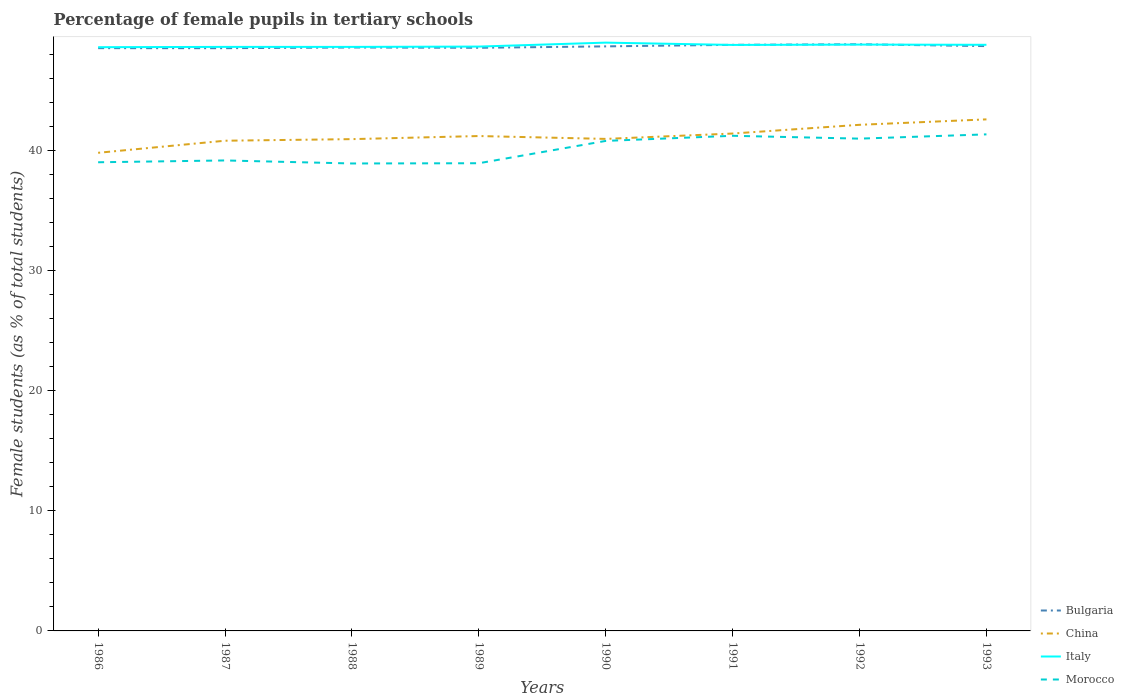How many different coloured lines are there?
Provide a succinct answer. 4. Does the line corresponding to Morocco intersect with the line corresponding to China?
Your response must be concise. No. Is the number of lines equal to the number of legend labels?
Offer a terse response. Yes. Across all years, what is the maximum percentage of female pupils in tertiary schools in Italy?
Offer a very short reply. 48.63. In which year was the percentage of female pupils in tertiary schools in Italy maximum?
Make the answer very short. 1986. What is the total percentage of female pupils in tertiary schools in Bulgaria in the graph?
Offer a terse response. -0.3. What is the difference between the highest and the second highest percentage of female pupils in tertiary schools in Bulgaria?
Your response must be concise. 0.33. What is the difference between the highest and the lowest percentage of female pupils in tertiary schools in Bulgaria?
Give a very brief answer. 4. Is the percentage of female pupils in tertiary schools in China strictly greater than the percentage of female pupils in tertiary schools in Italy over the years?
Your answer should be very brief. Yes. How many lines are there?
Make the answer very short. 4. What is the difference between two consecutive major ticks on the Y-axis?
Your response must be concise. 10. Are the values on the major ticks of Y-axis written in scientific E-notation?
Offer a very short reply. No. Does the graph contain grids?
Your answer should be compact. No. How many legend labels are there?
Your answer should be compact. 4. How are the legend labels stacked?
Your answer should be compact. Vertical. What is the title of the graph?
Make the answer very short. Percentage of female pupils in tertiary schools. Does "Albania" appear as one of the legend labels in the graph?
Offer a terse response. No. What is the label or title of the X-axis?
Your answer should be very brief. Years. What is the label or title of the Y-axis?
Offer a terse response. Female students (as % of total students). What is the Female students (as % of total students) in Bulgaria in 1986?
Ensure brevity in your answer.  48.55. What is the Female students (as % of total students) in China in 1986?
Keep it short and to the point. 39.83. What is the Female students (as % of total students) in Italy in 1986?
Give a very brief answer. 48.63. What is the Female students (as % of total students) in Morocco in 1986?
Offer a terse response. 39.04. What is the Female students (as % of total students) in Bulgaria in 1987?
Your answer should be compact. 48.55. What is the Female students (as % of total students) in China in 1987?
Give a very brief answer. 40.84. What is the Female students (as % of total students) of Italy in 1987?
Your response must be concise. 48.65. What is the Female students (as % of total students) in Morocco in 1987?
Offer a very short reply. 39.19. What is the Female students (as % of total students) of Bulgaria in 1988?
Make the answer very short. 48.6. What is the Female students (as % of total students) in China in 1988?
Provide a short and direct response. 40.97. What is the Female students (as % of total students) of Italy in 1988?
Keep it short and to the point. 48.65. What is the Female students (as % of total students) in Morocco in 1988?
Your answer should be compact. 38.94. What is the Female students (as % of total students) in Bulgaria in 1989?
Make the answer very short. 48.58. What is the Female students (as % of total students) in China in 1989?
Offer a very short reply. 41.23. What is the Female students (as % of total students) of Italy in 1989?
Your response must be concise. 48.68. What is the Female students (as % of total students) of Morocco in 1989?
Offer a very short reply. 38.96. What is the Female students (as % of total students) in Bulgaria in 1990?
Make the answer very short. 48.7. What is the Female students (as % of total students) in China in 1990?
Your answer should be compact. 40.99. What is the Female students (as % of total students) of Italy in 1990?
Make the answer very short. 49.01. What is the Female students (as % of total students) in Morocco in 1990?
Offer a very short reply. 40.82. What is the Female students (as % of total students) of Bulgaria in 1991?
Your answer should be compact. 48.83. What is the Female students (as % of total students) of China in 1991?
Keep it short and to the point. 41.44. What is the Female students (as % of total students) of Italy in 1991?
Give a very brief answer. 48.82. What is the Female students (as % of total students) of Morocco in 1991?
Give a very brief answer. 41.25. What is the Female students (as % of total students) of Bulgaria in 1992?
Your answer should be very brief. 48.87. What is the Female students (as % of total students) of China in 1992?
Give a very brief answer. 42.16. What is the Female students (as % of total students) in Italy in 1992?
Offer a very short reply. 48.85. What is the Female students (as % of total students) of Morocco in 1992?
Your answer should be compact. 41.01. What is the Female students (as % of total students) of Bulgaria in 1993?
Make the answer very short. 48.72. What is the Female students (as % of total students) of China in 1993?
Give a very brief answer. 42.62. What is the Female students (as % of total students) of Italy in 1993?
Your answer should be very brief. 48.83. What is the Female students (as % of total students) in Morocco in 1993?
Your response must be concise. 41.37. Across all years, what is the maximum Female students (as % of total students) in Bulgaria?
Your response must be concise. 48.87. Across all years, what is the maximum Female students (as % of total students) of China?
Your response must be concise. 42.62. Across all years, what is the maximum Female students (as % of total students) in Italy?
Your answer should be compact. 49.01. Across all years, what is the maximum Female students (as % of total students) in Morocco?
Your answer should be compact. 41.37. Across all years, what is the minimum Female students (as % of total students) in Bulgaria?
Make the answer very short. 48.55. Across all years, what is the minimum Female students (as % of total students) of China?
Provide a short and direct response. 39.83. Across all years, what is the minimum Female students (as % of total students) of Italy?
Your response must be concise. 48.63. Across all years, what is the minimum Female students (as % of total students) in Morocco?
Provide a succinct answer. 38.94. What is the total Female students (as % of total students) of Bulgaria in the graph?
Make the answer very short. 389.39. What is the total Female students (as % of total students) in China in the graph?
Your answer should be compact. 330.07. What is the total Female students (as % of total students) in Italy in the graph?
Your answer should be very brief. 390.12. What is the total Female students (as % of total students) in Morocco in the graph?
Ensure brevity in your answer.  320.59. What is the difference between the Female students (as % of total students) of Bulgaria in 1986 and that in 1987?
Ensure brevity in your answer.  0. What is the difference between the Female students (as % of total students) of China in 1986 and that in 1987?
Offer a terse response. -1.01. What is the difference between the Female students (as % of total students) in Italy in 1986 and that in 1987?
Your response must be concise. -0.03. What is the difference between the Female students (as % of total students) in Morocco in 1986 and that in 1987?
Your response must be concise. -0.15. What is the difference between the Female students (as % of total students) of Bulgaria in 1986 and that in 1988?
Give a very brief answer. -0.06. What is the difference between the Female students (as % of total students) of China in 1986 and that in 1988?
Your response must be concise. -1.14. What is the difference between the Female students (as % of total students) in Italy in 1986 and that in 1988?
Offer a very short reply. -0.03. What is the difference between the Female students (as % of total students) in Morocco in 1986 and that in 1988?
Ensure brevity in your answer.  0.1. What is the difference between the Female students (as % of total students) of Bulgaria in 1986 and that in 1989?
Offer a very short reply. -0.03. What is the difference between the Female students (as % of total students) in China in 1986 and that in 1989?
Offer a very short reply. -1.4. What is the difference between the Female students (as % of total students) in Italy in 1986 and that in 1989?
Offer a very short reply. -0.05. What is the difference between the Female students (as % of total students) in Morocco in 1986 and that in 1989?
Make the answer very short. 0.08. What is the difference between the Female students (as % of total students) in Bulgaria in 1986 and that in 1990?
Give a very brief answer. -0.15. What is the difference between the Female students (as % of total students) of China in 1986 and that in 1990?
Your answer should be compact. -1.16. What is the difference between the Female students (as % of total students) in Italy in 1986 and that in 1990?
Provide a short and direct response. -0.38. What is the difference between the Female students (as % of total students) in Morocco in 1986 and that in 1990?
Offer a very short reply. -1.78. What is the difference between the Female students (as % of total students) of Bulgaria in 1986 and that in 1991?
Your answer should be very brief. -0.28. What is the difference between the Female students (as % of total students) of China in 1986 and that in 1991?
Your answer should be compact. -1.61. What is the difference between the Female students (as % of total students) in Italy in 1986 and that in 1991?
Provide a short and direct response. -0.19. What is the difference between the Female students (as % of total students) of Morocco in 1986 and that in 1991?
Offer a terse response. -2.21. What is the difference between the Female students (as % of total students) in Bulgaria in 1986 and that in 1992?
Provide a short and direct response. -0.33. What is the difference between the Female students (as % of total students) in China in 1986 and that in 1992?
Offer a terse response. -2.33. What is the difference between the Female students (as % of total students) of Italy in 1986 and that in 1992?
Ensure brevity in your answer.  -0.22. What is the difference between the Female students (as % of total students) of Morocco in 1986 and that in 1992?
Provide a succinct answer. -1.97. What is the difference between the Female students (as % of total students) in Bulgaria in 1986 and that in 1993?
Your response must be concise. -0.17. What is the difference between the Female students (as % of total students) in China in 1986 and that in 1993?
Make the answer very short. -2.78. What is the difference between the Female students (as % of total students) of Italy in 1986 and that in 1993?
Offer a terse response. -0.2. What is the difference between the Female students (as % of total students) of Morocco in 1986 and that in 1993?
Provide a short and direct response. -2.32. What is the difference between the Female students (as % of total students) of Bulgaria in 1987 and that in 1988?
Ensure brevity in your answer.  -0.06. What is the difference between the Female students (as % of total students) of China in 1987 and that in 1988?
Ensure brevity in your answer.  -0.13. What is the difference between the Female students (as % of total students) of Italy in 1987 and that in 1988?
Offer a terse response. -0. What is the difference between the Female students (as % of total students) of Morocco in 1987 and that in 1988?
Provide a short and direct response. 0.25. What is the difference between the Female students (as % of total students) in Bulgaria in 1987 and that in 1989?
Offer a terse response. -0.03. What is the difference between the Female students (as % of total students) in China in 1987 and that in 1989?
Keep it short and to the point. -0.39. What is the difference between the Female students (as % of total students) of Italy in 1987 and that in 1989?
Offer a terse response. -0.03. What is the difference between the Female students (as % of total students) of Morocco in 1987 and that in 1989?
Offer a very short reply. 0.23. What is the difference between the Female students (as % of total students) of Bulgaria in 1987 and that in 1990?
Your answer should be compact. -0.15. What is the difference between the Female students (as % of total students) of China in 1987 and that in 1990?
Your response must be concise. -0.15. What is the difference between the Female students (as % of total students) in Italy in 1987 and that in 1990?
Provide a short and direct response. -0.36. What is the difference between the Female students (as % of total students) in Morocco in 1987 and that in 1990?
Keep it short and to the point. -1.63. What is the difference between the Female students (as % of total students) of Bulgaria in 1987 and that in 1991?
Keep it short and to the point. -0.28. What is the difference between the Female students (as % of total students) in China in 1987 and that in 1991?
Ensure brevity in your answer.  -0.6. What is the difference between the Female students (as % of total students) in Italy in 1987 and that in 1991?
Make the answer very short. -0.16. What is the difference between the Female students (as % of total students) of Morocco in 1987 and that in 1991?
Provide a succinct answer. -2.05. What is the difference between the Female students (as % of total students) in Bulgaria in 1987 and that in 1992?
Provide a succinct answer. -0.33. What is the difference between the Female students (as % of total students) in China in 1987 and that in 1992?
Keep it short and to the point. -1.33. What is the difference between the Female students (as % of total students) of Italy in 1987 and that in 1992?
Offer a terse response. -0.19. What is the difference between the Female students (as % of total students) of Morocco in 1987 and that in 1992?
Your answer should be compact. -1.82. What is the difference between the Female students (as % of total students) in Bulgaria in 1987 and that in 1993?
Ensure brevity in your answer.  -0.17. What is the difference between the Female students (as % of total students) in China in 1987 and that in 1993?
Offer a very short reply. -1.78. What is the difference between the Female students (as % of total students) of Italy in 1987 and that in 1993?
Your answer should be very brief. -0.18. What is the difference between the Female students (as % of total students) in Morocco in 1987 and that in 1993?
Offer a terse response. -2.17. What is the difference between the Female students (as % of total students) in Bulgaria in 1988 and that in 1989?
Provide a succinct answer. 0.03. What is the difference between the Female students (as % of total students) of China in 1988 and that in 1989?
Your response must be concise. -0.26. What is the difference between the Female students (as % of total students) of Italy in 1988 and that in 1989?
Offer a very short reply. -0.03. What is the difference between the Female students (as % of total students) of Morocco in 1988 and that in 1989?
Keep it short and to the point. -0.02. What is the difference between the Female students (as % of total students) in Bulgaria in 1988 and that in 1990?
Keep it short and to the point. -0.09. What is the difference between the Female students (as % of total students) of China in 1988 and that in 1990?
Give a very brief answer. -0.02. What is the difference between the Female students (as % of total students) of Italy in 1988 and that in 1990?
Ensure brevity in your answer.  -0.36. What is the difference between the Female students (as % of total students) of Morocco in 1988 and that in 1990?
Provide a short and direct response. -1.88. What is the difference between the Female students (as % of total students) of Bulgaria in 1988 and that in 1991?
Your response must be concise. -0.22. What is the difference between the Female students (as % of total students) of China in 1988 and that in 1991?
Give a very brief answer. -0.47. What is the difference between the Female students (as % of total students) in Italy in 1988 and that in 1991?
Your response must be concise. -0.16. What is the difference between the Female students (as % of total students) of Morocco in 1988 and that in 1991?
Ensure brevity in your answer.  -2.31. What is the difference between the Female students (as % of total students) of Bulgaria in 1988 and that in 1992?
Provide a short and direct response. -0.27. What is the difference between the Female students (as % of total students) in China in 1988 and that in 1992?
Make the answer very short. -1.19. What is the difference between the Female students (as % of total students) in Italy in 1988 and that in 1992?
Provide a succinct answer. -0.19. What is the difference between the Female students (as % of total students) of Morocco in 1988 and that in 1992?
Your answer should be very brief. -2.07. What is the difference between the Female students (as % of total students) in Bulgaria in 1988 and that in 1993?
Keep it short and to the point. -0.11. What is the difference between the Female students (as % of total students) of China in 1988 and that in 1993?
Offer a terse response. -1.65. What is the difference between the Female students (as % of total students) of Italy in 1988 and that in 1993?
Ensure brevity in your answer.  -0.17. What is the difference between the Female students (as % of total students) of Morocco in 1988 and that in 1993?
Offer a very short reply. -2.43. What is the difference between the Female students (as % of total students) of Bulgaria in 1989 and that in 1990?
Your answer should be compact. -0.12. What is the difference between the Female students (as % of total students) of China in 1989 and that in 1990?
Your response must be concise. 0.24. What is the difference between the Female students (as % of total students) of Italy in 1989 and that in 1990?
Keep it short and to the point. -0.33. What is the difference between the Female students (as % of total students) of Morocco in 1989 and that in 1990?
Offer a terse response. -1.86. What is the difference between the Female students (as % of total students) in Bulgaria in 1989 and that in 1991?
Offer a very short reply. -0.25. What is the difference between the Female students (as % of total students) of China in 1989 and that in 1991?
Offer a very short reply. -0.21. What is the difference between the Female students (as % of total students) in Italy in 1989 and that in 1991?
Give a very brief answer. -0.14. What is the difference between the Female students (as % of total students) in Morocco in 1989 and that in 1991?
Ensure brevity in your answer.  -2.29. What is the difference between the Female students (as % of total students) of Bulgaria in 1989 and that in 1992?
Offer a terse response. -0.3. What is the difference between the Female students (as % of total students) of China in 1989 and that in 1992?
Offer a very short reply. -0.94. What is the difference between the Female students (as % of total students) of Italy in 1989 and that in 1992?
Provide a succinct answer. -0.17. What is the difference between the Female students (as % of total students) in Morocco in 1989 and that in 1992?
Provide a short and direct response. -2.05. What is the difference between the Female students (as % of total students) in Bulgaria in 1989 and that in 1993?
Your response must be concise. -0.14. What is the difference between the Female students (as % of total students) in China in 1989 and that in 1993?
Provide a short and direct response. -1.39. What is the difference between the Female students (as % of total students) in Italy in 1989 and that in 1993?
Make the answer very short. -0.15. What is the difference between the Female students (as % of total students) of Morocco in 1989 and that in 1993?
Offer a very short reply. -2.4. What is the difference between the Female students (as % of total students) in Bulgaria in 1990 and that in 1991?
Offer a terse response. -0.13. What is the difference between the Female students (as % of total students) of China in 1990 and that in 1991?
Provide a succinct answer. -0.45. What is the difference between the Female students (as % of total students) in Italy in 1990 and that in 1991?
Provide a succinct answer. 0.19. What is the difference between the Female students (as % of total students) of Morocco in 1990 and that in 1991?
Give a very brief answer. -0.43. What is the difference between the Female students (as % of total students) in Bulgaria in 1990 and that in 1992?
Provide a succinct answer. -0.18. What is the difference between the Female students (as % of total students) of China in 1990 and that in 1992?
Your answer should be very brief. -1.17. What is the difference between the Female students (as % of total students) in Italy in 1990 and that in 1992?
Offer a very short reply. 0.16. What is the difference between the Female students (as % of total students) of Morocco in 1990 and that in 1992?
Give a very brief answer. -0.19. What is the difference between the Female students (as % of total students) of Bulgaria in 1990 and that in 1993?
Your answer should be compact. -0.02. What is the difference between the Female students (as % of total students) of China in 1990 and that in 1993?
Your answer should be very brief. -1.63. What is the difference between the Female students (as % of total students) of Italy in 1990 and that in 1993?
Offer a very short reply. 0.18. What is the difference between the Female students (as % of total students) of Morocco in 1990 and that in 1993?
Make the answer very short. -0.54. What is the difference between the Female students (as % of total students) of Bulgaria in 1991 and that in 1992?
Offer a very short reply. -0.05. What is the difference between the Female students (as % of total students) in China in 1991 and that in 1992?
Offer a terse response. -0.73. What is the difference between the Female students (as % of total students) of Italy in 1991 and that in 1992?
Your answer should be compact. -0.03. What is the difference between the Female students (as % of total students) in Morocco in 1991 and that in 1992?
Your response must be concise. 0.24. What is the difference between the Female students (as % of total students) in Bulgaria in 1991 and that in 1993?
Your response must be concise. 0.11. What is the difference between the Female students (as % of total students) in China in 1991 and that in 1993?
Offer a terse response. -1.18. What is the difference between the Female students (as % of total students) of Italy in 1991 and that in 1993?
Your answer should be very brief. -0.01. What is the difference between the Female students (as % of total students) of Morocco in 1991 and that in 1993?
Make the answer very short. -0.12. What is the difference between the Female students (as % of total students) of Bulgaria in 1992 and that in 1993?
Offer a terse response. 0.16. What is the difference between the Female students (as % of total students) in China in 1992 and that in 1993?
Give a very brief answer. -0.45. What is the difference between the Female students (as % of total students) of Italy in 1992 and that in 1993?
Offer a terse response. 0.02. What is the difference between the Female students (as % of total students) of Morocco in 1992 and that in 1993?
Keep it short and to the point. -0.36. What is the difference between the Female students (as % of total students) of Bulgaria in 1986 and the Female students (as % of total students) of China in 1987?
Your answer should be very brief. 7.71. What is the difference between the Female students (as % of total students) in Bulgaria in 1986 and the Female students (as % of total students) in Italy in 1987?
Your response must be concise. -0.11. What is the difference between the Female students (as % of total students) in Bulgaria in 1986 and the Female students (as % of total students) in Morocco in 1987?
Give a very brief answer. 9.35. What is the difference between the Female students (as % of total students) of China in 1986 and the Female students (as % of total students) of Italy in 1987?
Your answer should be very brief. -8.82. What is the difference between the Female students (as % of total students) in China in 1986 and the Female students (as % of total students) in Morocco in 1987?
Make the answer very short. 0.64. What is the difference between the Female students (as % of total students) of Italy in 1986 and the Female students (as % of total students) of Morocco in 1987?
Your answer should be very brief. 9.43. What is the difference between the Female students (as % of total students) in Bulgaria in 1986 and the Female students (as % of total students) in China in 1988?
Make the answer very short. 7.58. What is the difference between the Female students (as % of total students) of Bulgaria in 1986 and the Female students (as % of total students) of Italy in 1988?
Offer a very short reply. -0.11. What is the difference between the Female students (as % of total students) of Bulgaria in 1986 and the Female students (as % of total students) of Morocco in 1988?
Ensure brevity in your answer.  9.61. What is the difference between the Female students (as % of total students) of China in 1986 and the Female students (as % of total students) of Italy in 1988?
Provide a succinct answer. -8.82. What is the difference between the Female students (as % of total students) of China in 1986 and the Female students (as % of total students) of Morocco in 1988?
Keep it short and to the point. 0.89. What is the difference between the Female students (as % of total students) in Italy in 1986 and the Female students (as % of total students) in Morocco in 1988?
Your response must be concise. 9.69. What is the difference between the Female students (as % of total students) in Bulgaria in 1986 and the Female students (as % of total students) in China in 1989?
Give a very brief answer. 7.32. What is the difference between the Female students (as % of total students) in Bulgaria in 1986 and the Female students (as % of total students) in Italy in 1989?
Keep it short and to the point. -0.13. What is the difference between the Female students (as % of total students) of Bulgaria in 1986 and the Female students (as % of total students) of Morocco in 1989?
Ensure brevity in your answer.  9.59. What is the difference between the Female students (as % of total students) in China in 1986 and the Female students (as % of total students) in Italy in 1989?
Provide a succinct answer. -8.85. What is the difference between the Female students (as % of total students) in China in 1986 and the Female students (as % of total students) in Morocco in 1989?
Give a very brief answer. 0.87. What is the difference between the Female students (as % of total students) of Italy in 1986 and the Female students (as % of total students) of Morocco in 1989?
Provide a short and direct response. 9.67. What is the difference between the Female students (as % of total students) of Bulgaria in 1986 and the Female students (as % of total students) of China in 1990?
Give a very brief answer. 7.56. What is the difference between the Female students (as % of total students) of Bulgaria in 1986 and the Female students (as % of total students) of Italy in 1990?
Provide a short and direct response. -0.46. What is the difference between the Female students (as % of total students) of Bulgaria in 1986 and the Female students (as % of total students) of Morocco in 1990?
Ensure brevity in your answer.  7.73. What is the difference between the Female students (as % of total students) of China in 1986 and the Female students (as % of total students) of Italy in 1990?
Your response must be concise. -9.18. What is the difference between the Female students (as % of total students) of China in 1986 and the Female students (as % of total students) of Morocco in 1990?
Make the answer very short. -0.99. What is the difference between the Female students (as % of total students) of Italy in 1986 and the Female students (as % of total students) of Morocco in 1990?
Ensure brevity in your answer.  7.81. What is the difference between the Female students (as % of total students) in Bulgaria in 1986 and the Female students (as % of total students) in China in 1991?
Make the answer very short. 7.11. What is the difference between the Female students (as % of total students) of Bulgaria in 1986 and the Female students (as % of total students) of Italy in 1991?
Make the answer very short. -0.27. What is the difference between the Female students (as % of total students) of Bulgaria in 1986 and the Female students (as % of total students) of Morocco in 1991?
Make the answer very short. 7.3. What is the difference between the Female students (as % of total students) of China in 1986 and the Female students (as % of total students) of Italy in 1991?
Give a very brief answer. -8.99. What is the difference between the Female students (as % of total students) in China in 1986 and the Female students (as % of total students) in Morocco in 1991?
Offer a terse response. -1.42. What is the difference between the Female students (as % of total students) of Italy in 1986 and the Female students (as % of total students) of Morocco in 1991?
Your answer should be very brief. 7.38. What is the difference between the Female students (as % of total students) in Bulgaria in 1986 and the Female students (as % of total students) in China in 1992?
Offer a terse response. 6.39. What is the difference between the Female students (as % of total students) of Bulgaria in 1986 and the Female students (as % of total students) of Italy in 1992?
Keep it short and to the point. -0.3. What is the difference between the Female students (as % of total students) of Bulgaria in 1986 and the Female students (as % of total students) of Morocco in 1992?
Make the answer very short. 7.54. What is the difference between the Female students (as % of total students) in China in 1986 and the Female students (as % of total students) in Italy in 1992?
Ensure brevity in your answer.  -9.02. What is the difference between the Female students (as % of total students) of China in 1986 and the Female students (as % of total students) of Morocco in 1992?
Keep it short and to the point. -1.18. What is the difference between the Female students (as % of total students) of Italy in 1986 and the Female students (as % of total students) of Morocco in 1992?
Provide a succinct answer. 7.62. What is the difference between the Female students (as % of total students) in Bulgaria in 1986 and the Female students (as % of total students) in China in 1993?
Provide a succinct answer. 5.93. What is the difference between the Female students (as % of total students) in Bulgaria in 1986 and the Female students (as % of total students) in Italy in 1993?
Keep it short and to the point. -0.28. What is the difference between the Female students (as % of total students) in Bulgaria in 1986 and the Female students (as % of total students) in Morocco in 1993?
Your response must be concise. 7.18. What is the difference between the Female students (as % of total students) of China in 1986 and the Female students (as % of total students) of Italy in 1993?
Make the answer very short. -9. What is the difference between the Female students (as % of total students) in China in 1986 and the Female students (as % of total students) in Morocco in 1993?
Your response must be concise. -1.54. What is the difference between the Female students (as % of total students) of Italy in 1986 and the Female students (as % of total students) of Morocco in 1993?
Provide a succinct answer. 7.26. What is the difference between the Female students (as % of total students) in Bulgaria in 1987 and the Female students (as % of total students) in China in 1988?
Your response must be concise. 7.58. What is the difference between the Female students (as % of total students) of Bulgaria in 1987 and the Female students (as % of total students) of Italy in 1988?
Keep it short and to the point. -0.11. What is the difference between the Female students (as % of total students) of Bulgaria in 1987 and the Female students (as % of total students) of Morocco in 1988?
Provide a succinct answer. 9.6. What is the difference between the Female students (as % of total students) in China in 1987 and the Female students (as % of total students) in Italy in 1988?
Make the answer very short. -7.82. What is the difference between the Female students (as % of total students) of China in 1987 and the Female students (as % of total students) of Morocco in 1988?
Make the answer very short. 1.9. What is the difference between the Female students (as % of total students) in Italy in 1987 and the Female students (as % of total students) in Morocco in 1988?
Make the answer very short. 9.71. What is the difference between the Female students (as % of total students) of Bulgaria in 1987 and the Female students (as % of total students) of China in 1989?
Your response must be concise. 7.32. What is the difference between the Female students (as % of total students) in Bulgaria in 1987 and the Female students (as % of total students) in Italy in 1989?
Make the answer very short. -0.13. What is the difference between the Female students (as % of total students) in Bulgaria in 1987 and the Female students (as % of total students) in Morocco in 1989?
Offer a terse response. 9.58. What is the difference between the Female students (as % of total students) of China in 1987 and the Female students (as % of total students) of Italy in 1989?
Provide a short and direct response. -7.84. What is the difference between the Female students (as % of total students) in China in 1987 and the Female students (as % of total students) in Morocco in 1989?
Your answer should be compact. 1.88. What is the difference between the Female students (as % of total students) of Italy in 1987 and the Female students (as % of total students) of Morocco in 1989?
Keep it short and to the point. 9.69. What is the difference between the Female students (as % of total students) in Bulgaria in 1987 and the Female students (as % of total students) in China in 1990?
Your response must be concise. 7.56. What is the difference between the Female students (as % of total students) of Bulgaria in 1987 and the Female students (as % of total students) of Italy in 1990?
Make the answer very short. -0.46. What is the difference between the Female students (as % of total students) of Bulgaria in 1987 and the Female students (as % of total students) of Morocco in 1990?
Offer a very short reply. 7.72. What is the difference between the Female students (as % of total students) of China in 1987 and the Female students (as % of total students) of Italy in 1990?
Make the answer very short. -8.17. What is the difference between the Female students (as % of total students) of China in 1987 and the Female students (as % of total students) of Morocco in 1990?
Offer a very short reply. 0.02. What is the difference between the Female students (as % of total students) of Italy in 1987 and the Female students (as % of total students) of Morocco in 1990?
Your answer should be compact. 7.83. What is the difference between the Female students (as % of total students) of Bulgaria in 1987 and the Female students (as % of total students) of China in 1991?
Your answer should be very brief. 7.11. What is the difference between the Female students (as % of total students) in Bulgaria in 1987 and the Female students (as % of total students) in Italy in 1991?
Keep it short and to the point. -0.27. What is the difference between the Female students (as % of total students) in Bulgaria in 1987 and the Female students (as % of total students) in Morocco in 1991?
Your answer should be very brief. 7.3. What is the difference between the Female students (as % of total students) of China in 1987 and the Female students (as % of total students) of Italy in 1991?
Your response must be concise. -7.98. What is the difference between the Female students (as % of total students) in China in 1987 and the Female students (as % of total students) in Morocco in 1991?
Your answer should be compact. -0.41. What is the difference between the Female students (as % of total students) in Italy in 1987 and the Female students (as % of total students) in Morocco in 1991?
Keep it short and to the point. 7.41. What is the difference between the Female students (as % of total students) in Bulgaria in 1987 and the Female students (as % of total students) in China in 1992?
Your response must be concise. 6.38. What is the difference between the Female students (as % of total students) of Bulgaria in 1987 and the Female students (as % of total students) of Italy in 1992?
Provide a short and direct response. -0.3. What is the difference between the Female students (as % of total students) of Bulgaria in 1987 and the Female students (as % of total students) of Morocco in 1992?
Offer a terse response. 7.54. What is the difference between the Female students (as % of total students) in China in 1987 and the Female students (as % of total students) in Italy in 1992?
Offer a terse response. -8.01. What is the difference between the Female students (as % of total students) of China in 1987 and the Female students (as % of total students) of Morocco in 1992?
Provide a short and direct response. -0.17. What is the difference between the Female students (as % of total students) in Italy in 1987 and the Female students (as % of total students) in Morocco in 1992?
Provide a short and direct response. 7.64. What is the difference between the Female students (as % of total students) of Bulgaria in 1987 and the Female students (as % of total students) of China in 1993?
Give a very brief answer. 5.93. What is the difference between the Female students (as % of total students) of Bulgaria in 1987 and the Female students (as % of total students) of Italy in 1993?
Offer a terse response. -0.28. What is the difference between the Female students (as % of total students) of Bulgaria in 1987 and the Female students (as % of total students) of Morocco in 1993?
Provide a succinct answer. 7.18. What is the difference between the Female students (as % of total students) of China in 1987 and the Female students (as % of total students) of Italy in 1993?
Provide a short and direct response. -7.99. What is the difference between the Female students (as % of total students) in China in 1987 and the Female students (as % of total students) in Morocco in 1993?
Your response must be concise. -0.53. What is the difference between the Female students (as % of total students) of Italy in 1987 and the Female students (as % of total students) of Morocco in 1993?
Provide a short and direct response. 7.29. What is the difference between the Female students (as % of total students) of Bulgaria in 1988 and the Female students (as % of total students) of China in 1989?
Make the answer very short. 7.38. What is the difference between the Female students (as % of total students) of Bulgaria in 1988 and the Female students (as % of total students) of Italy in 1989?
Provide a succinct answer. -0.08. What is the difference between the Female students (as % of total students) in Bulgaria in 1988 and the Female students (as % of total students) in Morocco in 1989?
Your answer should be very brief. 9.64. What is the difference between the Female students (as % of total students) of China in 1988 and the Female students (as % of total students) of Italy in 1989?
Your response must be concise. -7.71. What is the difference between the Female students (as % of total students) of China in 1988 and the Female students (as % of total students) of Morocco in 1989?
Ensure brevity in your answer.  2.01. What is the difference between the Female students (as % of total students) in Italy in 1988 and the Female students (as % of total students) in Morocco in 1989?
Provide a succinct answer. 9.69. What is the difference between the Female students (as % of total students) of Bulgaria in 1988 and the Female students (as % of total students) of China in 1990?
Offer a very short reply. 7.62. What is the difference between the Female students (as % of total students) in Bulgaria in 1988 and the Female students (as % of total students) in Italy in 1990?
Ensure brevity in your answer.  -0.41. What is the difference between the Female students (as % of total students) in Bulgaria in 1988 and the Female students (as % of total students) in Morocco in 1990?
Your answer should be very brief. 7.78. What is the difference between the Female students (as % of total students) of China in 1988 and the Female students (as % of total students) of Italy in 1990?
Provide a short and direct response. -8.04. What is the difference between the Female students (as % of total students) of China in 1988 and the Female students (as % of total students) of Morocco in 1990?
Make the answer very short. 0.15. What is the difference between the Female students (as % of total students) of Italy in 1988 and the Female students (as % of total students) of Morocco in 1990?
Make the answer very short. 7.83. What is the difference between the Female students (as % of total students) of Bulgaria in 1988 and the Female students (as % of total students) of China in 1991?
Provide a short and direct response. 7.17. What is the difference between the Female students (as % of total students) in Bulgaria in 1988 and the Female students (as % of total students) in Italy in 1991?
Provide a succinct answer. -0.21. What is the difference between the Female students (as % of total students) in Bulgaria in 1988 and the Female students (as % of total students) in Morocco in 1991?
Ensure brevity in your answer.  7.36. What is the difference between the Female students (as % of total students) in China in 1988 and the Female students (as % of total students) in Italy in 1991?
Make the answer very short. -7.85. What is the difference between the Female students (as % of total students) in China in 1988 and the Female students (as % of total students) in Morocco in 1991?
Offer a terse response. -0.28. What is the difference between the Female students (as % of total students) in Italy in 1988 and the Female students (as % of total students) in Morocco in 1991?
Make the answer very short. 7.41. What is the difference between the Female students (as % of total students) of Bulgaria in 1988 and the Female students (as % of total students) of China in 1992?
Your response must be concise. 6.44. What is the difference between the Female students (as % of total students) in Bulgaria in 1988 and the Female students (as % of total students) in Italy in 1992?
Offer a very short reply. -0.24. What is the difference between the Female students (as % of total students) in Bulgaria in 1988 and the Female students (as % of total students) in Morocco in 1992?
Make the answer very short. 7.59. What is the difference between the Female students (as % of total students) of China in 1988 and the Female students (as % of total students) of Italy in 1992?
Offer a very short reply. -7.88. What is the difference between the Female students (as % of total students) of China in 1988 and the Female students (as % of total students) of Morocco in 1992?
Make the answer very short. -0.04. What is the difference between the Female students (as % of total students) of Italy in 1988 and the Female students (as % of total students) of Morocco in 1992?
Provide a succinct answer. 7.64. What is the difference between the Female students (as % of total students) in Bulgaria in 1988 and the Female students (as % of total students) in China in 1993?
Offer a terse response. 5.99. What is the difference between the Female students (as % of total students) in Bulgaria in 1988 and the Female students (as % of total students) in Italy in 1993?
Your response must be concise. -0.22. What is the difference between the Female students (as % of total students) of Bulgaria in 1988 and the Female students (as % of total students) of Morocco in 1993?
Make the answer very short. 7.24. What is the difference between the Female students (as % of total students) in China in 1988 and the Female students (as % of total students) in Italy in 1993?
Your answer should be very brief. -7.86. What is the difference between the Female students (as % of total students) in China in 1988 and the Female students (as % of total students) in Morocco in 1993?
Your answer should be very brief. -0.4. What is the difference between the Female students (as % of total students) in Italy in 1988 and the Female students (as % of total students) in Morocco in 1993?
Your answer should be very brief. 7.29. What is the difference between the Female students (as % of total students) of Bulgaria in 1989 and the Female students (as % of total students) of China in 1990?
Your answer should be very brief. 7.59. What is the difference between the Female students (as % of total students) in Bulgaria in 1989 and the Female students (as % of total students) in Italy in 1990?
Give a very brief answer. -0.43. What is the difference between the Female students (as % of total students) of Bulgaria in 1989 and the Female students (as % of total students) of Morocco in 1990?
Keep it short and to the point. 7.76. What is the difference between the Female students (as % of total students) in China in 1989 and the Female students (as % of total students) in Italy in 1990?
Your response must be concise. -7.78. What is the difference between the Female students (as % of total students) in China in 1989 and the Female students (as % of total students) in Morocco in 1990?
Your response must be concise. 0.41. What is the difference between the Female students (as % of total students) of Italy in 1989 and the Female students (as % of total students) of Morocco in 1990?
Offer a terse response. 7.86. What is the difference between the Female students (as % of total students) in Bulgaria in 1989 and the Female students (as % of total students) in China in 1991?
Your answer should be very brief. 7.14. What is the difference between the Female students (as % of total students) in Bulgaria in 1989 and the Female students (as % of total students) in Italy in 1991?
Offer a terse response. -0.24. What is the difference between the Female students (as % of total students) in Bulgaria in 1989 and the Female students (as % of total students) in Morocco in 1991?
Offer a very short reply. 7.33. What is the difference between the Female students (as % of total students) in China in 1989 and the Female students (as % of total students) in Italy in 1991?
Your answer should be very brief. -7.59. What is the difference between the Female students (as % of total students) of China in 1989 and the Female students (as % of total students) of Morocco in 1991?
Make the answer very short. -0.02. What is the difference between the Female students (as % of total students) in Italy in 1989 and the Female students (as % of total students) in Morocco in 1991?
Make the answer very short. 7.43. What is the difference between the Female students (as % of total students) of Bulgaria in 1989 and the Female students (as % of total students) of China in 1992?
Ensure brevity in your answer.  6.42. What is the difference between the Female students (as % of total students) of Bulgaria in 1989 and the Female students (as % of total students) of Italy in 1992?
Offer a very short reply. -0.27. What is the difference between the Female students (as % of total students) in Bulgaria in 1989 and the Female students (as % of total students) in Morocco in 1992?
Provide a succinct answer. 7.57. What is the difference between the Female students (as % of total students) in China in 1989 and the Female students (as % of total students) in Italy in 1992?
Provide a short and direct response. -7.62. What is the difference between the Female students (as % of total students) of China in 1989 and the Female students (as % of total students) of Morocco in 1992?
Provide a short and direct response. 0.22. What is the difference between the Female students (as % of total students) in Italy in 1989 and the Female students (as % of total students) in Morocco in 1992?
Offer a very short reply. 7.67. What is the difference between the Female students (as % of total students) in Bulgaria in 1989 and the Female students (as % of total students) in China in 1993?
Provide a succinct answer. 5.96. What is the difference between the Female students (as % of total students) in Bulgaria in 1989 and the Female students (as % of total students) in Italy in 1993?
Offer a terse response. -0.25. What is the difference between the Female students (as % of total students) of Bulgaria in 1989 and the Female students (as % of total students) of Morocco in 1993?
Provide a short and direct response. 7.21. What is the difference between the Female students (as % of total students) of China in 1989 and the Female students (as % of total students) of Italy in 1993?
Make the answer very short. -7.6. What is the difference between the Female students (as % of total students) in China in 1989 and the Female students (as % of total students) in Morocco in 1993?
Your answer should be very brief. -0.14. What is the difference between the Female students (as % of total students) in Italy in 1989 and the Female students (as % of total students) in Morocco in 1993?
Ensure brevity in your answer.  7.31. What is the difference between the Female students (as % of total students) in Bulgaria in 1990 and the Female students (as % of total students) in China in 1991?
Your answer should be very brief. 7.26. What is the difference between the Female students (as % of total students) of Bulgaria in 1990 and the Female students (as % of total students) of Italy in 1991?
Provide a succinct answer. -0.12. What is the difference between the Female students (as % of total students) of Bulgaria in 1990 and the Female students (as % of total students) of Morocco in 1991?
Make the answer very short. 7.45. What is the difference between the Female students (as % of total students) of China in 1990 and the Female students (as % of total students) of Italy in 1991?
Your answer should be compact. -7.83. What is the difference between the Female students (as % of total students) in China in 1990 and the Female students (as % of total students) in Morocco in 1991?
Your response must be concise. -0.26. What is the difference between the Female students (as % of total students) of Italy in 1990 and the Female students (as % of total students) of Morocco in 1991?
Offer a terse response. 7.76. What is the difference between the Female students (as % of total students) in Bulgaria in 1990 and the Female students (as % of total students) in China in 1992?
Provide a succinct answer. 6.53. What is the difference between the Female students (as % of total students) in Bulgaria in 1990 and the Female students (as % of total students) in Italy in 1992?
Provide a short and direct response. -0.15. What is the difference between the Female students (as % of total students) in Bulgaria in 1990 and the Female students (as % of total students) in Morocco in 1992?
Make the answer very short. 7.69. What is the difference between the Female students (as % of total students) of China in 1990 and the Female students (as % of total students) of Italy in 1992?
Provide a short and direct response. -7.86. What is the difference between the Female students (as % of total students) in China in 1990 and the Female students (as % of total students) in Morocco in 1992?
Provide a succinct answer. -0.02. What is the difference between the Female students (as % of total students) of Italy in 1990 and the Female students (as % of total students) of Morocco in 1992?
Your answer should be compact. 8. What is the difference between the Female students (as % of total students) in Bulgaria in 1990 and the Female students (as % of total students) in China in 1993?
Offer a terse response. 6.08. What is the difference between the Female students (as % of total students) in Bulgaria in 1990 and the Female students (as % of total students) in Italy in 1993?
Your answer should be very brief. -0.13. What is the difference between the Female students (as % of total students) of Bulgaria in 1990 and the Female students (as % of total students) of Morocco in 1993?
Offer a terse response. 7.33. What is the difference between the Female students (as % of total students) of China in 1990 and the Female students (as % of total students) of Italy in 1993?
Give a very brief answer. -7.84. What is the difference between the Female students (as % of total students) of China in 1990 and the Female students (as % of total students) of Morocco in 1993?
Keep it short and to the point. -0.38. What is the difference between the Female students (as % of total students) of Italy in 1990 and the Female students (as % of total students) of Morocco in 1993?
Keep it short and to the point. 7.64. What is the difference between the Female students (as % of total students) of Bulgaria in 1991 and the Female students (as % of total students) of China in 1992?
Make the answer very short. 6.66. What is the difference between the Female students (as % of total students) in Bulgaria in 1991 and the Female students (as % of total students) in Italy in 1992?
Your answer should be very brief. -0.02. What is the difference between the Female students (as % of total students) of Bulgaria in 1991 and the Female students (as % of total students) of Morocco in 1992?
Your answer should be compact. 7.82. What is the difference between the Female students (as % of total students) of China in 1991 and the Female students (as % of total students) of Italy in 1992?
Your answer should be very brief. -7.41. What is the difference between the Female students (as % of total students) of China in 1991 and the Female students (as % of total students) of Morocco in 1992?
Offer a very short reply. 0.43. What is the difference between the Female students (as % of total students) in Italy in 1991 and the Female students (as % of total students) in Morocco in 1992?
Give a very brief answer. 7.81. What is the difference between the Female students (as % of total students) in Bulgaria in 1991 and the Female students (as % of total students) in China in 1993?
Make the answer very short. 6.21. What is the difference between the Female students (as % of total students) in Bulgaria in 1991 and the Female students (as % of total students) in Italy in 1993?
Offer a very short reply. -0. What is the difference between the Female students (as % of total students) of Bulgaria in 1991 and the Female students (as % of total students) of Morocco in 1993?
Ensure brevity in your answer.  7.46. What is the difference between the Female students (as % of total students) in China in 1991 and the Female students (as % of total students) in Italy in 1993?
Your answer should be very brief. -7.39. What is the difference between the Female students (as % of total students) of China in 1991 and the Female students (as % of total students) of Morocco in 1993?
Provide a short and direct response. 0.07. What is the difference between the Female students (as % of total students) in Italy in 1991 and the Female students (as % of total students) in Morocco in 1993?
Ensure brevity in your answer.  7.45. What is the difference between the Female students (as % of total students) of Bulgaria in 1992 and the Female students (as % of total students) of China in 1993?
Your response must be concise. 6.26. What is the difference between the Female students (as % of total students) in Bulgaria in 1992 and the Female students (as % of total students) in Italy in 1993?
Give a very brief answer. 0.04. What is the difference between the Female students (as % of total students) of Bulgaria in 1992 and the Female students (as % of total students) of Morocco in 1993?
Provide a succinct answer. 7.51. What is the difference between the Female students (as % of total students) of China in 1992 and the Female students (as % of total students) of Italy in 1993?
Provide a short and direct response. -6.67. What is the difference between the Female students (as % of total students) of China in 1992 and the Female students (as % of total students) of Morocco in 1993?
Your answer should be compact. 0.8. What is the difference between the Female students (as % of total students) in Italy in 1992 and the Female students (as % of total students) in Morocco in 1993?
Make the answer very short. 7.48. What is the average Female students (as % of total students) of Bulgaria per year?
Your answer should be very brief. 48.67. What is the average Female students (as % of total students) of China per year?
Provide a succinct answer. 41.26. What is the average Female students (as % of total students) of Italy per year?
Offer a terse response. 48.76. What is the average Female students (as % of total students) in Morocco per year?
Provide a short and direct response. 40.07. In the year 1986, what is the difference between the Female students (as % of total students) of Bulgaria and Female students (as % of total students) of China?
Offer a very short reply. 8.72. In the year 1986, what is the difference between the Female students (as % of total students) in Bulgaria and Female students (as % of total students) in Italy?
Offer a very short reply. -0.08. In the year 1986, what is the difference between the Female students (as % of total students) of Bulgaria and Female students (as % of total students) of Morocco?
Your answer should be very brief. 9.51. In the year 1986, what is the difference between the Female students (as % of total students) of China and Female students (as % of total students) of Italy?
Your answer should be compact. -8.8. In the year 1986, what is the difference between the Female students (as % of total students) in China and Female students (as % of total students) in Morocco?
Give a very brief answer. 0.79. In the year 1986, what is the difference between the Female students (as % of total students) in Italy and Female students (as % of total students) in Morocco?
Your answer should be compact. 9.59. In the year 1987, what is the difference between the Female students (as % of total students) of Bulgaria and Female students (as % of total students) of China?
Provide a succinct answer. 7.71. In the year 1987, what is the difference between the Female students (as % of total students) in Bulgaria and Female students (as % of total students) in Italy?
Provide a succinct answer. -0.11. In the year 1987, what is the difference between the Female students (as % of total students) of Bulgaria and Female students (as % of total students) of Morocco?
Your answer should be compact. 9.35. In the year 1987, what is the difference between the Female students (as % of total students) in China and Female students (as % of total students) in Italy?
Provide a succinct answer. -7.82. In the year 1987, what is the difference between the Female students (as % of total students) in China and Female students (as % of total students) in Morocco?
Your response must be concise. 1.64. In the year 1987, what is the difference between the Female students (as % of total students) of Italy and Female students (as % of total students) of Morocco?
Offer a terse response. 9.46. In the year 1988, what is the difference between the Female students (as % of total students) of Bulgaria and Female students (as % of total students) of China?
Offer a terse response. 7.63. In the year 1988, what is the difference between the Female students (as % of total students) in Bulgaria and Female students (as % of total students) in Italy?
Your answer should be compact. -0.05. In the year 1988, what is the difference between the Female students (as % of total students) of Bulgaria and Female students (as % of total students) of Morocco?
Provide a succinct answer. 9.66. In the year 1988, what is the difference between the Female students (as % of total students) of China and Female students (as % of total students) of Italy?
Provide a succinct answer. -7.68. In the year 1988, what is the difference between the Female students (as % of total students) of China and Female students (as % of total students) of Morocco?
Give a very brief answer. 2.03. In the year 1988, what is the difference between the Female students (as % of total students) of Italy and Female students (as % of total students) of Morocco?
Your answer should be very brief. 9.71. In the year 1989, what is the difference between the Female students (as % of total students) in Bulgaria and Female students (as % of total students) in China?
Your answer should be compact. 7.35. In the year 1989, what is the difference between the Female students (as % of total students) of Bulgaria and Female students (as % of total students) of Italy?
Offer a very short reply. -0.1. In the year 1989, what is the difference between the Female students (as % of total students) in Bulgaria and Female students (as % of total students) in Morocco?
Your answer should be compact. 9.62. In the year 1989, what is the difference between the Female students (as % of total students) of China and Female students (as % of total students) of Italy?
Provide a short and direct response. -7.45. In the year 1989, what is the difference between the Female students (as % of total students) in China and Female students (as % of total students) in Morocco?
Provide a short and direct response. 2.27. In the year 1989, what is the difference between the Female students (as % of total students) in Italy and Female students (as % of total students) in Morocco?
Provide a short and direct response. 9.72. In the year 1990, what is the difference between the Female students (as % of total students) of Bulgaria and Female students (as % of total students) of China?
Make the answer very short. 7.71. In the year 1990, what is the difference between the Female students (as % of total students) of Bulgaria and Female students (as % of total students) of Italy?
Provide a short and direct response. -0.31. In the year 1990, what is the difference between the Female students (as % of total students) of Bulgaria and Female students (as % of total students) of Morocco?
Ensure brevity in your answer.  7.88. In the year 1990, what is the difference between the Female students (as % of total students) in China and Female students (as % of total students) in Italy?
Provide a short and direct response. -8.02. In the year 1990, what is the difference between the Female students (as % of total students) of China and Female students (as % of total students) of Morocco?
Ensure brevity in your answer.  0.17. In the year 1990, what is the difference between the Female students (as % of total students) in Italy and Female students (as % of total students) in Morocco?
Keep it short and to the point. 8.19. In the year 1991, what is the difference between the Female students (as % of total students) in Bulgaria and Female students (as % of total students) in China?
Provide a succinct answer. 7.39. In the year 1991, what is the difference between the Female students (as % of total students) of Bulgaria and Female students (as % of total students) of Italy?
Your answer should be very brief. 0.01. In the year 1991, what is the difference between the Female students (as % of total students) in Bulgaria and Female students (as % of total students) in Morocco?
Provide a short and direct response. 7.58. In the year 1991, what is the difference between the Female students (as % of total students) of China and Female students (as % of total students) of Italy?
Your answer should be compact. -7.38. In the year 1991, what is the difference between the Female students (as % of total students) of China and Female students (as % of total students) of Morocco?
Offer a very short reply. 0.19. In the year 1991, what is the difference between the Female students (as % of total students) in Italy and Female students (as % of total students) in Morocco?
Provide a short and direct response. 7.57. In the year 1992, what is the difference between the Female students (as % of total students) of Bulgaria and Female students (as % of total students) of China?
Keep it short and to the point. 6.71. In the year 1992, what is the difference between the Female students (as % of total students) in Bulgaria and Female students (as % of total students) in Italy?
Provide a succinct answer. 0.03. In the year 1992, what is the difference between the Female students (as % of total students) in Bulgaria and Female students (as % of total students) in Morocco?
Offer a terse response. 7.86. In the year 1992, what is the difference between the Female students (as % of total students) of China and Female students (as % of total students) of Italy?
Your answer should be compact. -6.68. In the year 1992, what is the difference between the Female students (as % of total students) of China and Female students (as % of total students) of Morocco?
Give a very brief answer. 1.15. In the year 1992, what is the difference between the Female students (as % of total students) in Italy and Female students (as % of total students) in Morocco?
Your answer should be very brief. 7.84. In the year 1993, what is the difference between the Female students (as % of total students) in Bulgaria and Female students (as % of total students) in China?
Provide a succinct answer. 6.1. In the year 1993, what is the difference between the Female students (as % of total students) in Bulgaria and Female students (as % of total students) in Italy?
Keep it short and to the point. -0.11. In the year 1993, what is the difference between the Female students (as % of total students) in Bulgaria and Female students (as % of total students) in Morocco?
Offer a terse response. 7.35. In the year 1993, what is the difference between the Female students (as % of total students) in China and Female students (as % of total students) in Italy?
Your response must be concise. -6.21. In the year 1993, what is the difference between the Female students (as % of total students) of China and Female students (as % of total students) of Morocco?
Ensure brevity in your answer.  1.25. In the year 1993, what is the difference between the Female students (as % of total students) of Italy and Female students (as % of total students) of Morocco?
Your answer should be compact. 7.46. What is the ratio of the Female students (as % of total students) of Bulgaria in 1986 to that in 1987?
Offer a terse response. 1. What is the ratio of the Female students (as % of total students) of China in 1986 to that in 1987?
Keep it short and to the point. 0.98. What is the ratio of the Female students (as % of total students) of Morocco in 1986 to that in 1987?
Ensure brevity in your answer.  1. What is the ratio of the Female students (as % of total students) of Bulgaria in 1986 to that in 1988?
Your answer should be compact. 1. What is the ratio of the Female students (as % of total students) in China in 1986 to that in 1988?
Provide a succinct answer. 0.97. What is the ratio of the Female students (as % of total students) in Italy in 1986 to that in 1988?
Ensure brevity in your answer.  1. What is the ratio of the Female students (as % of total students) in Morocco in 1986 to that in 1988?
Ensure brevity in your answer.  1. What is the ratio of the Female students (as % of total students) in China in 1986 to that in 1989?
Keep it short and to the point. 0.97. What is the ratio of the Female students (as % of total students) in Morocco in 1986 to that in 1989?
Offer a terse response. 1. What is the ratio of the Female students (as % of total students) in China in 1986 to that in 1990?
Provide a succinct answer. 0.97. What is the ratio of the Female students (as % of total students) in Morocco in 1986 to that in 1990?
Provide a succinct answer. 0.96. What is the ratio of the Female students (as % of total students) of Bulgaria in 1986 to that in 1991?
Provide a succinct answer. 0.99. What is the ratio of the Female students (as % of total students) in China in 1986 to that in 1991?
Offer a very short reply. 0.96. What is the ratio of the Female students (as % of total students) in Morocco in 1986 to that in 1991?
Your answer should be very brief. 0.95. What is the ratio of the Female students (as % of total students) in Bulgaria in 1986 to that in 1992?
Provide a succinct answer. 0.99. What is the ratio of the Female students (as % of total students) in China in 1986 to that in 1992?
Keep it short and to the point. 0.94. What is the ratio of the Female students (as % of total students) in Morocco in 1986 to that in 1992?
Make the answer very short. 0.95. What is the ratio of the Female students (as % of total students) of Bulgaria in 1986 to that in 1993?
Provide a succinct answer. 1. What is the ratio of the Female students (as % of total students) of China in 1986 to that in 1993?
Your response must be concise. 0.93. What is the ratio of the Female students (as % of total students) in Morocco in 1986 to that in 1993?
Make the answer very short. 0.94. What is the ratio of the Female students (as % of total students) of China in 1987 to that in 1988?
Provide a short and direct response. 1. What is the ratio of the Female students (as % of total students) of Morocco in 1987 to that in 1988?
Offer a very short reply. 1.01. What is the ratio of the Female students (as % of total students) of Morocco in 1987 to that in 1989?
Ensure brevity in your answer.  1.01. What is the ratio of the Female students (as % of total students) in Italy in 1987 to that in 1990?
Your answer should be very brief. 0.99. What is the ratio of the Female students (as % of total students) in Morocco in 1987 to that in 1990?
Make the answer very short. 0.96. What is the ratio of the Female students (as % of total students) in China in 1987 to that in 1991?
Your answer should be very brief. 0.99. What is the ratio of the Female students (as % of total students) in Italy in 1987 to that in 1991?
Your answer should be compact. 1. What is the ratio of the Female students (as % of total students) of Morocco in 1987 to that in 1991?
Give a very brief answer. 0.95. What is the ratio of the Female students (as % of total students) of Bulgaria in 1987 to that in 1992?
Provide a short and direct response. 0.99. What is the ratio of the Female students (as % of total students) in China in 1987 to that in 1992?
Make the answer very short. 0.97. What is the ratio of the Female students (as % of total students) of Italy in 1987 to that in 1992?
Offer a terse response. 1. What is the ratio of the Female students (as % of total students) in Morocco in 1987 to that in 1992?
Offer a terse response. 0.96. What is the ratio of the Female students (as % of total students) in China in 1987 to that in 1993?
Ensure brevity in your answer.  0.96. What is the ratio of the Female students (as % of total students) in Morocco in 1987 to that in 1993?
Give a very brief answer. 0.95. What is the ratio of the Female students (as % of total students) of China in 1988 to that in 1989?
Give a very brief answer. 0.99. What is the ratio of the Female students (as % of total students) in Italy in 1988 to that in 1989?
Your answer should be very brief. 1. What is the ratio of the Female students (as % of total students) in Morocco in 1988 to that in 1989?
Your answer should be compact. 1. What is the ratio of the Female students (as % of total students) of Morocco in 1988 to that in 1990?
Offer a very short reply. 0.95. What is the ratio of the Female students (as % of total students) of China in 1988 to that in 1991?
Offer a very short reply. 0.99. What is the ratio of the Female students (as % of total students) in Morocco in 1988 to that in 1991?
Make the answer very short. 0.94. What is the ratio of the Female students (as % of total students) in China in 1988 to that in 1992?
Provide a succinct answer. 0.97. What is the ratio of the Female students (as % of total students) of Morocco in 1988 to that in 1992?
Provide a succinct answer. 0.95. What is the ratio of the Female students (as % of total students) of Bulgaria in 1988 to that in 1993?
Ensure brevity in your answer.  1. What is the ratio of the Female students (as % of total students) of China in 1988 to that in 1993?
Provide a short and direct response. 0.96. What is the ratio of the Female students (as % of total students) in Morocco in 1988 to that in 1993?
Keep it short and to the point. 0.94. What is the ratio of the Female students (as % of total students) in China in 1989 to that in 1990?
Make the answer very short. 1.01. What is the ratio of the Female students (as % of total students) of Italy in 1989 to that in 1990?
Offer a very short reply. 0.99. What is the ratio of the Female students (as % of total students) of Morocco in 1989 to that in 1990?
Offer a terse response. 0.95. What is the ratio of the Female students (as % of total students) of Bulgaria in 1989 to that in 1991?
Make the answer very short. 0.99. What is the ratio of the Female students (as % of total students) in Morocco in 1989 to that in 1991?
Your answer should be compact. 0.94. What is the ratio of the Female students (as % of total students) of China in 1989 to that in 1992?
Offer a very short reply. 0.98. What is the ratio of the Female students (as % of total students) of Bulgaria in 1989 to that in 1993?
Keep it short and to the point. 1. What is the ratio of the Female students (as % of total students) in China in 1989 to that in 1993?
Ensure brevity in your answer.  0.97. What is the ratio of the Female students (as % of total students) in Italy in 1989 to that in 1993?
Give a very brief answer. 1. What is the ratio of the Female students (as % of total students) of Morocco in 1989 to that in 1993?
Ensure brevity in your answer.  0.94. What is the ratio of the Female students (as % of total students) of China in 1990 to that in 1991?
Provide a short and direct response. 0.99. What is the ratio of the Female students (as % of total students) of Italy in 1990 to that in 1991?
Offer a very short reply. 1. What is the ratio of the Female students (as % of total students) of Morocco in 1990 to that in 1991?
Give a very brief answer. 0.99. What is the ratio of the Female students (as % of total students) of Bulgaria in 1990 to that in 1992?
Keep it short and to the point. 1. What is the ratio of the Female students (as % of total students) in China in 1990 to that in 1992?
Make the answer very short. 0.97. What is the ratio of the Female students (as % of total students) in Italy in 1990 to that in 1992?
Your response must be concise. 1. What is the ratio of the Female students (as % of total students) in Morocco in 1990 to that in 1992?
Keep it short and to the point. 1. What is the ratio of the Female students (as % of total students) in Bulgaria in 1990 to that in 1993?
Your response must be concise. 1. What is the ratio of the Female students (as % of total students) of China in 1990 to that in 1993?
Provide a succinct answer. 0.96. What is the ratio of the Female students (as % of total students) of Italy in 1990 to that in 1993?
Your answer should be compact. 1. What is the ratio of the Female students (as % of total students) of China in 1991 to that in 1992?
Your answer should be compact. 0.98. What is the ratio of the Female students (as % of total students) in Italy in 1991 to that in 1992?
Keep it short and to the point. 1. What is the ratio of the Female students (as % of total students) in Morocco in 1991 to that in 1992?
Your answer should be compact. 1.01. What is the ratio of the Female students (as % of total students) of Bulgaria in 1991 to that in 1993?
Your answer should be very brief. 1. What is the ratio of the Female students (as % of total students) in China in 1991 to that in 1993?
Provide a short and direct response. 0.97. What is the ratio of the Female students (as % of total students) in Italy in 1991 to that in 1993?
Provide a succinct answer. 1. What is the ratio of the Female students (as % of total students) in Morocco in 1991 to that in 1993?
Provide a short and direct response. 1. What is the ratio of the Female students (as % of total students) of Bulgaria in 1992 to that in 1993?
Your response must be concise. 1. What is the ratio of the Female students (as % of total students) in Italy in 1992 to that in 1993?
Provide a succinct answer. 1. What is the difference between the highest and the second highest Female students (as % of total students) of Bulgaria?
Offer a terse response. 0.05. What is the difference between the highest and the second highest Female students (as % of total students) in China?
Your answer should be compact. 0.45. What is the difference between the highest and the second highest Female students (as % of total students) in Italy?
Ensure brevity in your answer.  0.16. What is the difference between the highest and the second highest Female students (as % of total students) in Morocco?
Give a very brief answer. 0.12. What is the difference between the highest and the lowest Female students (as % of total students) in Bulgaria?
Provide a succinct answer. 0.33. What is the difference between the highest and the lowest Female students (as % of total students) in China?
Your response must be concise. 2.78. What is the difference between the highest and the lowest Female students (as % of total students) of Italy?
Provide a short and direct response. 0.38. What is the difference between the highest and the lowest Female students (as % of total students) of Morocco?
Your answer should be compact. 2.43. 